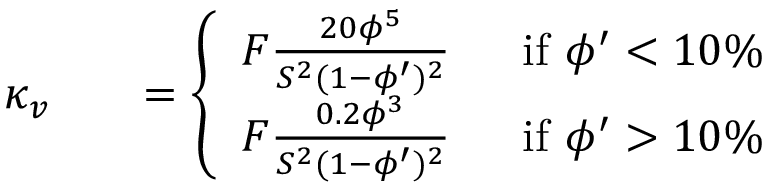<formula> <loc_0><loc_0><loc_500><loc_500>\begin{array} { r l r } { \kappa _ { v } } & { = \left \{ \begin{array} { l l } { F \frac { 2 0 \phi ^ { 5 } } { S ^ { 2 } ( 1 - \phi ^ { \prime } ) ^ { 2 } } \, } & { i f \phi ^ { \prime } < 1 0 \% } \\ { F \frac { 0 . 2 \phi ^ { 3 } } { S ^ { 2 } ( 1 - \phi ^ { \prime } ) ^ { 2 } } \, } & { i f \phi ^ { \prime } > 1 0 \% } \end{array} } \end{array}</formula> 